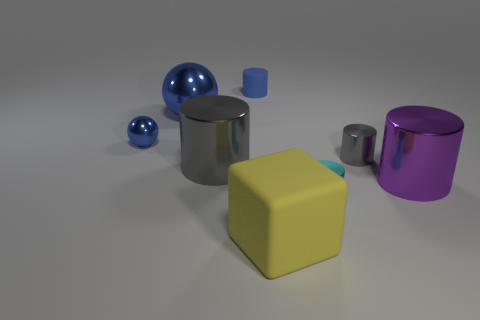Do the small sphere and the tiny cylinder that is on the left side of the large yellow matte block have the same color?
Your answer should be compact. Yes. There is another metallic sphere that is the same color as the small metallic ball; what is its size?
Keep it short and to the point. Large. What shape is the shiny object that is the same color as the large shiny ball?
Your response must be concise. Sphere. What number of other things are the same shape as the yellow rubber thing?
Ensure brevity in your answer.  0. There is a small blue object to the right of the big object left of the gray object that is on the left side of the large yellow block; what is its material?
Offer a very short reply. Rubber. Is the number of big purple things that are left of the blue rubber thing the same as the number of tiny metal things?
Offer a terse response. No. Is the material of the gray object to the left of the cyan cylinder the same as the gray cylinder right of the rubber cylinder?
Give a very brief answer. Yes. Is there anything else that has the same material as the purple thing?
Make the answer very short. Yes. There is a big shiny object right of the small rubber thing; is it the same shape as the matte object in front of the large blue thing?
Give a very brief answer. No. Are there fewer cyan cylinders to the left of the big rubber block than small blue matte balls?
Your response must be concise. No. 